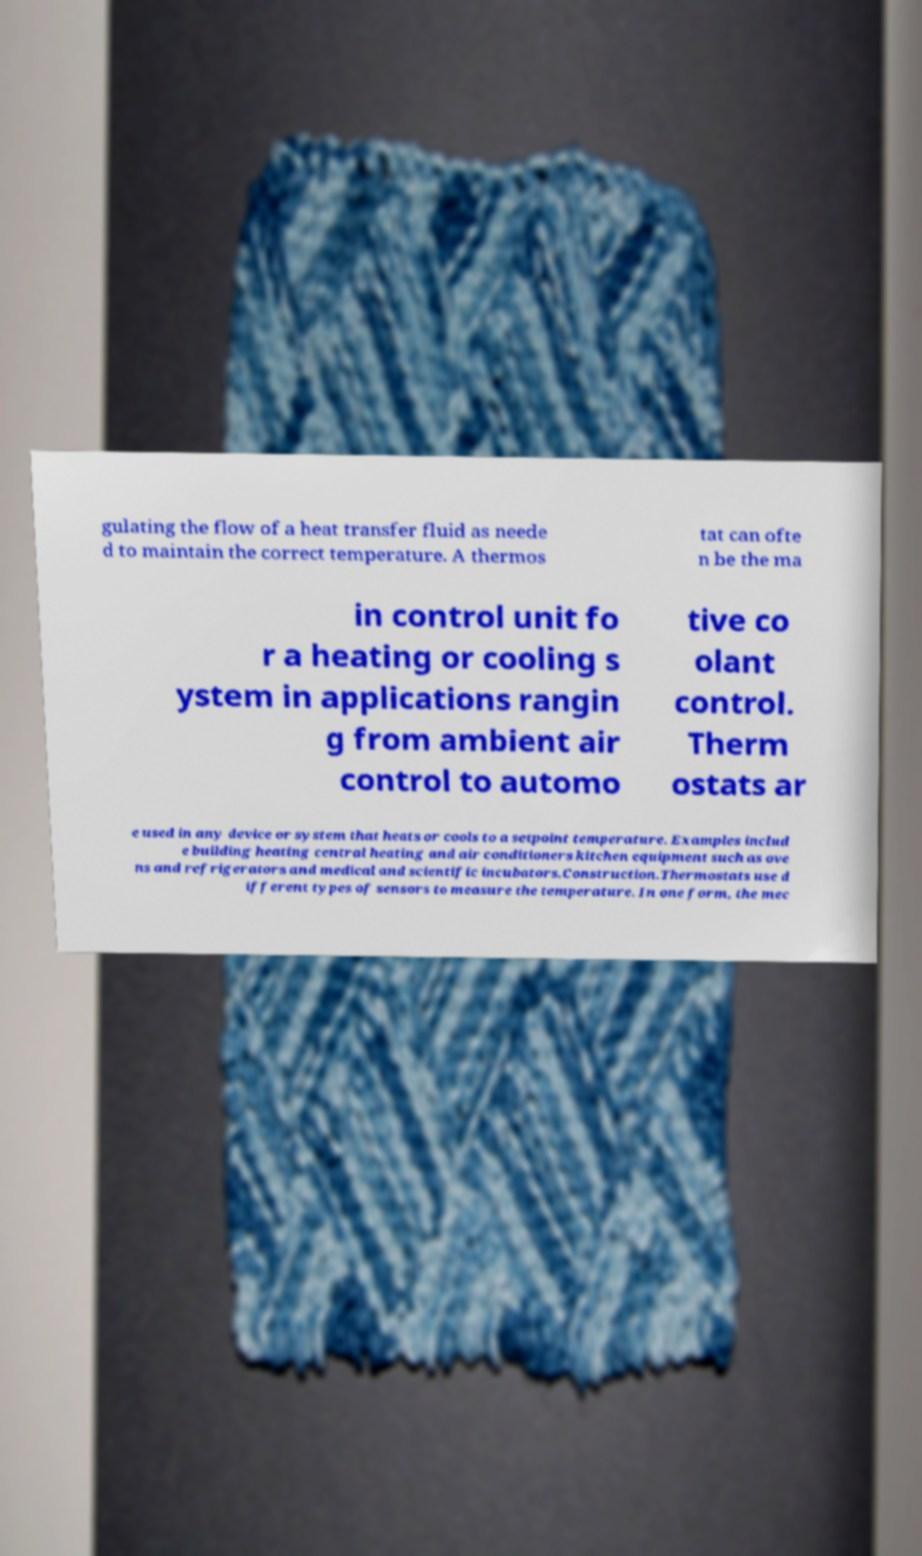What messages or text are displayed in this image? I need them in a readable, typed format. gulating the flow of a heat transfer fluid as neede d to maintain the correct temperature. A thermos tat can ofte n be the ma in control unit fo r a heating or cooling s ystem in applications rangin g from ambient air control to automo tive co olant control. Therm ostats ar e used in any device or system that heats or cools to a setpoint temperature. Examples includ e building heating central heating and air conditioners kitchen equipment such as ove ns and refrigerators and medical and scientific incubators.Construction.Thermostats use d ifferent types of sensors to measure the temperature. In one form, the mec 